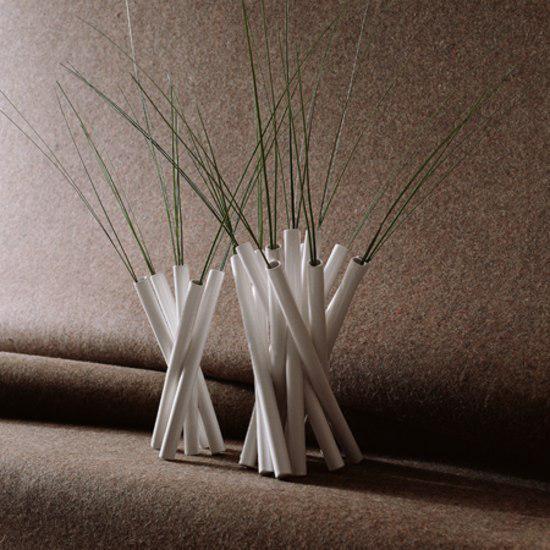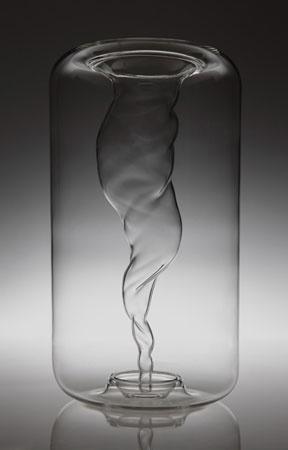The first image is the image on the left, the second image is the image on the right. Considering the images on both sides, is "Floral arrangements are in all vases." valid? Answer yes or no. No. 